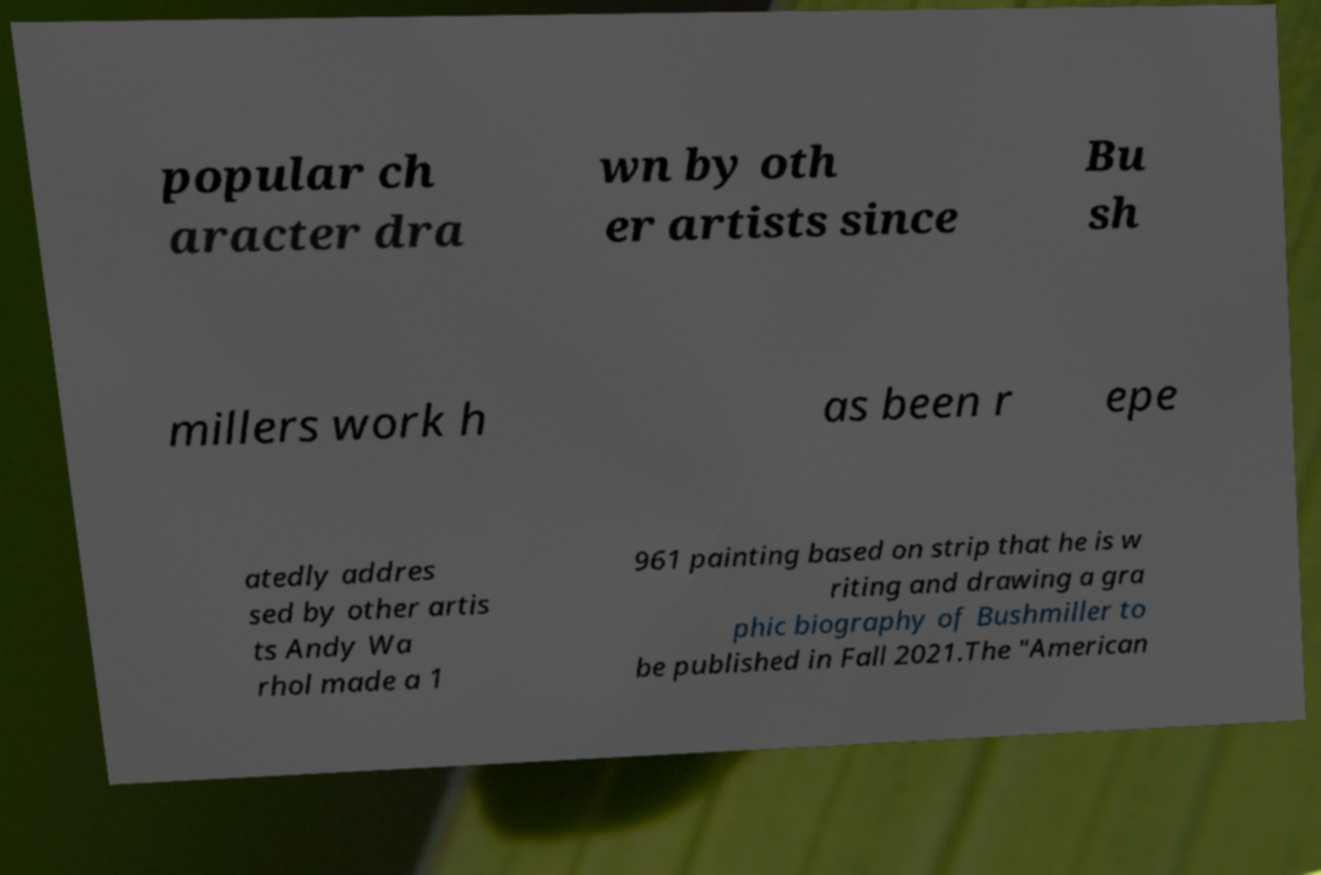Please read and relay the text visible in this image. What does it say? popular ch aracter dra wn by oth er artists since Bu sh millers work h as been r epe atedly addres sed by other artis ts Andy Wa rhol made a 1 961 painting based on strip that he is w riting and drawing a gra phic biography of Bushmiller to be published in Fall 2021.The "American 